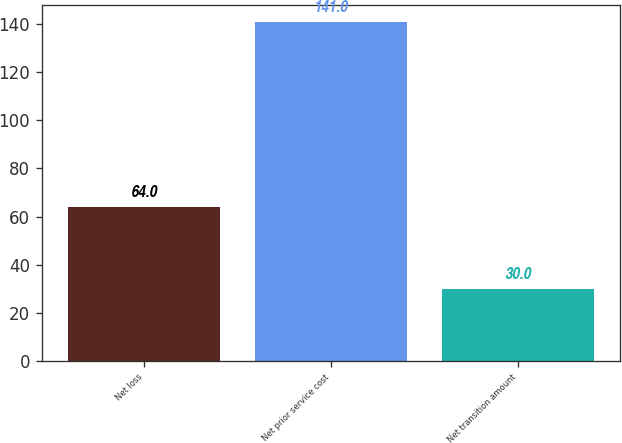Convert chart to OTSL. <chart><loc_0><loc_0><loc_500><loc_500><bar_chart><fcel>Net loss<fcel>Net prior service cost<fcel>Net transition amount<nl><fcel>64<fcel>141<fcel>30<nl></chart> 